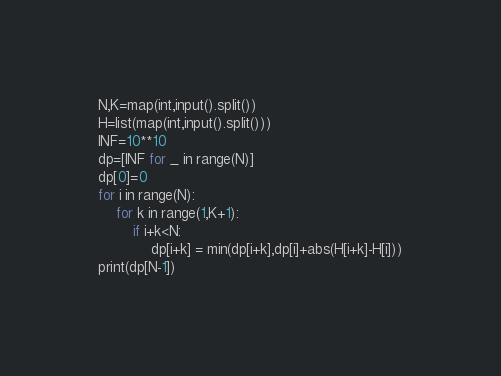<code> <loc_0><loc_0><loc_500><loc_500><_Python_>N,K=map(int,input().split())
H=list(map(int,input().split()))
INF=10**10
dp=[INF for _ in range(N)]
dp[0]=0
for i in range(N):
    for k in range(1,K+1):
        if i+k<N:
            dp[i+k] = min(dp[i+k],dp[i]+abs(H[i+k]-H[i]))
print(dp[N-1])</code> 